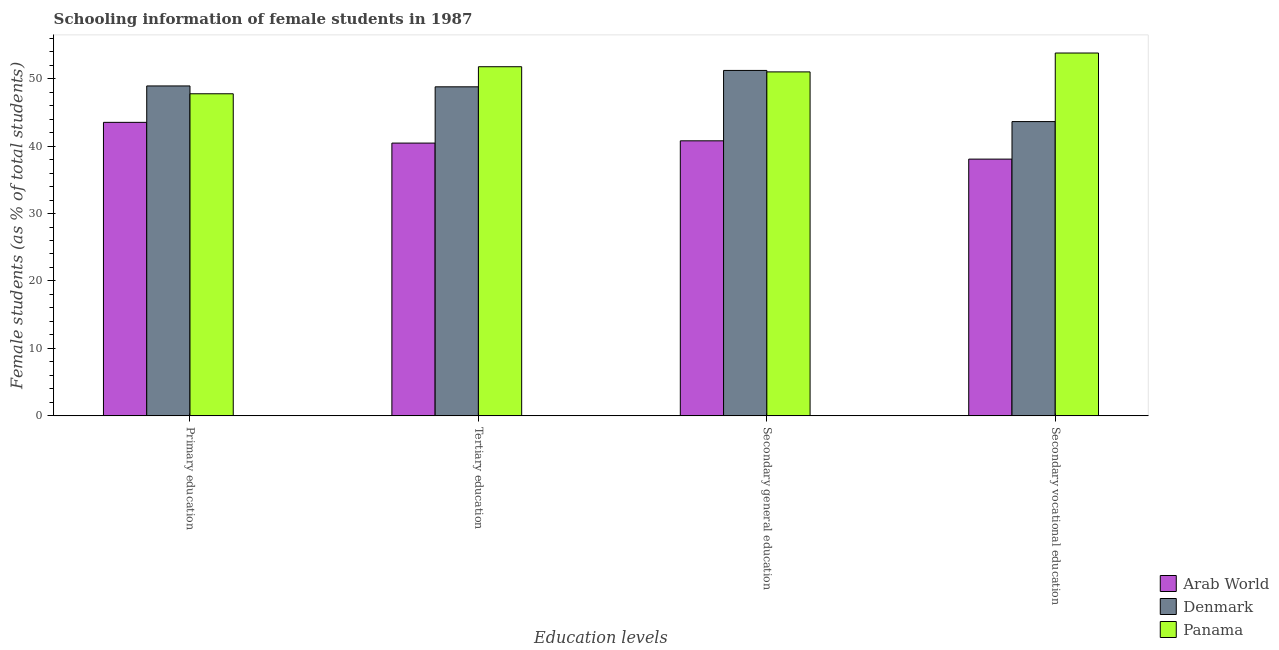Are the number of bars per tick equal to the number of legend labels?
Provide a short and direct response. Yes. What is the label of the 3rd group of bars from the left?
Ensure brevity in your answer.  Secondary general education. What is the percentage of female students in primary education in Panama?
Make the answer very short. 47.75. Across all countries, what is the maximum percentage of female students in primary education?
Offer a terse response. 48.92. Across all countries, what is the minimum percentage of female students in secondary education?
Ensure brevity in your answer.  40.78. In which country was the percentage of female students in secondary education minimum?
Your answer should be compact. Arab World. What is the total percentage of female students in tertiary education in the graph?
Ensure brevity in your answer.  140.99. What is the difference between the percentage of female students in secondary vocational education in Arab World and that in Panama?
Your answer should be very brief. -15.73. What is the difference between the percentage of female students in secondary vocational education in Panama and the percentage of female students in primary education in Arab World?
Provide a succinct answer. 10.28. What is the average percentage of female students in secondary education per country?
Ensure brevity in your answer.  47.66. What is the difference between the percentage of female students in secondary education and percentage of female students in primary education in Panama?
Offer a terse response. 3.24. What is the ratio of the percentage of female students in primary education in Arab World to that in Denmark?
Your answer should be compact. 0.89. Is the percentage of female students in secondary vocational education in Panama less than that in Arab World?
Give a very brief answer. No. What is the difference between the highest and the second highest percentage of female students in secondary vocational education?
Give a very brief answer. 10.17. What is the difference between the highest and the lowest percentage of female students in tertiary education?
Your response must be concise. 11.32. In how many countries, is the percentage of female students in primary education greater than the average percentage of female students in primary education taken over all countries?
Provide a short and direct response. 2. What does the 1st bar from the left in Secondary vocational education represents?
Make the answer very short. Arab World. What does the 3rd bar from the right in Secondary general education represents?
Your response must be concise. Arab World. How many bars are there?
Your answer should be compact. 12. Are all the bars in the graph horizontal?
Your answer should be very brief. No. How many countries are there in the graph?
Offer a very short reply. 3. Are the values on the major ticks of Y-axis written in scientific E-notation?
Give a very brief answer. No. Does the graph contain any zero values?
Give a very brief answer. No. Does the graph contain grids?
Your response must be concise. No. How many legend labels are there?
Provide a short and direct response. 3. What is the title of the graph?
Provide a short and direct response. Schooling information of female students in 1987. What is the label or title of the X-axis?
Offer a very short reply. Education levels. What is the label or title of the Y-axis?
Offer a terse response. Female students (as % of total students). What is the Female students (as % of total students) in Arab World in Primary education?
Offer a terse response. 43.52. What is the Female students (as % of total students) of Denmark in Primary education?
Your response must be concise. 48.92. What is the Female students (as % of total students) of Panama in Primary education?
Your answer should be compact. 47.75. What is the Female students (as % of total students) of Arab World in Tertiary education?
Keep it short and to the point. 40.44. What is the Female students (as % of total students) in Denmark in Tertiary education?
Offer a very short reply. 48.79. What is the Female students (as % of total students) of Panama in Tertiary education?
Your answer should be very brief. 51.76. What is the Female students (as % of total students) in Arab World in Secondary general education?
Make the answer very short. 40.78. What is the Female students (as % of total students) of Denmark in Secondary general education?
Keep it short and to the point. 51.21. What is the Female students (as % of total students) in Panama in Secondary general education?
Make the answer very short. 51. What is the Female students (as % of total students) of Arab World in Secondary vocational education?
Give a very brief answer. 38.07. What is the Female students (as % of total students) of Denmark in Secondary vocational education?
Provide a succinct answer. 43.63. What is the Female students (as % of total students) of Panama in Secondary vocational education?
Ensure brevity in your answer.  53.8. Across all Education levels, what is the maximum Female students (as % of total students) of Arab World?
Give a very brief answer. 43.52. Across all Education levels, what is the maximum Female students (as % of total students) of Denmark?
Provide a succinct answer. 51.21. Across all Education levels, what is the maximum Female students (as % of total students) of Panama?
Provide a succinct answer. 53.8. Across all Education levels, what is the minimum Female students (as % of total students) of Arab World?
Offer a terse response. 38.07. Across all Education levels, what is the minimum Female students (as % of total students) in Denmark?
Make the answer very short. 43.63. Across all Education levels, what is the minimum Female students (as % of total students) of Panama?
Give a very brief answer. 47.75. What is the total Female students (as % of total students) of Arab World in the graph?
Offer a terse response. 162.81. What is the total Female students (as % of total students) in Denmark in the graph?
Your answer should be very brief. 192.54. What is the total Female students (as % of total students) in Panama in the graph?
Give a very brief answer. 204.31. What is the difference between the Female students (as % of total students) in Arab World in Primary education and that in Tertiary education?
Your answer should be very brief. 3.07. What is the difference between the Female students (as % of total students) in Denmark in Primary education and that in Tertiary education?
Offer a very short reply. 0.13. What is the difference between the Female students (as % of total students) of Panama in Primary education and that in Tertiary education?
Ensure brevity in your answer.  -4.01. What is the difference between the Female students (as % of total students) of Arab World in Primary education and that in Secondary general education?
Give a very brief answer. 2.74. What is the difference between the Female students (as % of total students) in Denmark in Primary education and that in Secondary general education?
Offer a very short reply. -2.3. What is the difference between the Female students (as % of total students) of Panama in Primary education and that in Secondary general education?
Make the answer very short. -3.24. What is the difference between the Female students (as % of total students) of Arab World in Primary education and that in Secondary vocational education?
Offer a very short reply. 5.45. What is the difference between the Female students (as % of total students) in Denmark in Primary education and that in Secondary vocational education?
Give a very brief answer. 5.29. What is the difference between the Female students (as % of total students) of Panama in Primary education and that in Secondary vocational education?
Give a very brief answer. -6.04. What is the difference between the Female students (as % of total students) in Arab World in Tertiary education and that in Secondary general education?
Make the answer very short. -0.33. What is the difference between the Female students (as % of total students) in Denmark in Tertiary education and that in Secondary general education?
Keep it short and to the point. -2.43. What is the difference between the Female students (as % of total students) in Panama in Tertiary education and that in Secondary general education?
Keep it short and to the point. 0.77. What is the difference between the Female students (as % of total students) in Arab World in Tertiary education and that in Secondary vocational education?
Offer a very short reply. 2.38. What is the difference between the Female students (as % of total students) of Denmark in Tertiary education and that in Secondary vocational education?
Provide a succinct answer. 5.16. What is the difference between the Female students (as % of total students) of Panama in Tertiary education and that in Secondary vocational education?
Give a very brief answer. -2.03. What is the difference between the Female students (as % of total students) in Arab World in Secondary general education and that in Secondary vocational education?
Offer a very short reply. 2.71. What is the difference between the Female students (as % of total students) in Denmark in Secondary general education and that in Secondary vocational education?
Your answer should be very brief. 7.58. What is the difference between the Female students (as % of total students) in Panama in Secondary general education and that in Secondary vocational education?
Offer a terse response. -2.8. What is the difference between the Female students (as % of total students) in Arab World in Primary education and the Female students (as % of total students) in Denmark in Tertiary education?
Keep it short and to the point. -5.27. What is the difference between the Female students (as % of total students) of Arab World in Primary education and the Female students (as % of total students) of Panama in Tertiary education?
Give a very brief answer. -8.25. What is the difference between the Female students (as % of total students) of Denmark in Primary education and the Female students (as % of total students) of Panama in Tertiary education?
Keep it short and to the point. -2.85. What is the difference between the Female students (as % of total students) of Arab World in Primary education and the Female students (as % of total students) of Denmark in Secondary general education?
Offer a very short reply. -7.7. What is the difference between the Female students (as % of total students) of Arab World in Primary education and the Female students (as % of total students) of Panama in Secondary general education?
Make the answer very short. -7.48. What is the difference between the Female students (as % of total students) in Denmark in Primary education and the Female students (as % of total students) in Panama in Secondary general education?
Your answer should be very brief. -2.08. What is the difference between the Female students (as % of total students) in Arab World in Primary education and the Female students (as % of total students) in Denmark in Secondary vocational education?
Your answer should be compact. -0.11. What is the difference between the Female students (as % of total students) in Arab World in Primary education and the Female students (as % of total students) in Panama in Secondary vocational education?
Provide a succinct answer. -10.28. What is the difference between the Female students (as % of total students) of Denmark in Primary education and the Female students (as % of total students) of Panama in Secondary vocational education?
Provide a succinct answer. -4.88. What is the difference between the Female students (as % of total students) of Arab World in Tertiary education and the Female students (as % of total students) of Denmark in Secondary general education?
Ensure brevity in your answer.  -10.77. What is the difference between the Female students (as % of total students) of Arab World in Tertiary education and the Female students (as % of total students) of Panama in Secondary general education?
Offer a very short reply. -10.55. What is the difference between the Female students (as % of total students) of Denmark in Tertiary education and the Female students (as % of total students) of Panama in Secondary general education?
Offer a very short reply. -2.21. What is the difference between the Female students (as % of total students) of Arab World in Tertiary education and the Female students (as % of total students) of Denmark in Secondary vocational education?
Offer a very short reply. -3.19. What is the difference between the Female students (as % of total students) of Arab World in Tertiary education and the Female students (as % of total students) of Panama in Secondary vocational education?
Give a very brief answer. -13.35. What is the difference between the Female students (as % of total students) of Denmark in Tertiary education and the Female students (as % of total students) of Panama in Secondary vocational education?
Provide a short and direct response. -5.01. What is the difference between the Female students (as % of total students) of Arab World in Secondary general education and the Female students (as % of total students) of Denmark in Secondary vocational education?
Your response must be concise. -2.85. What is the difference between the Female students (as % of total students) in Arab World in Secondary general education and the Female students (as % of total students) in Panama in Secondary vocational education?
Keep it short and to the point. -13.02. What is the difference between the Female students (as % of total students) of Denmark in Secondary general education and the Female students (as % of total students) of Panama in Secondary vocational education?
Your response must be concise. -2.58. What is the average Female students (as % of total students) of Arab World per Education levels?
Make the answer very short. 40.7. What is the average Female students (as % of total students) of Denmark per Education levels?
Offer a terse response. 48.14. What is the average Female students (as % of total students) in Panama per Education levels?
Your answer should be compact. 51.08. What is the difference between the Female students (as % of total students) in Arab World and Female students (as % of total students) in Denmark in Primary education?
Provide a succinct answer. -5.4. What is the difference between the Female students (as % of total students) in Arab World and Female students (as % of total students) in Panama in Primary education?
Give a very brief answer. -4.24. What is the difference between the Female students (as % of total students) of Denmark and Female students (as % of total students) of Panama in Primary education?
Ensure brevity in your answer.  1.16. What is the difference between the Female students (as % of total students) in Arab World and Female students (as % of total students) in Denmark in Tertiary education?
Your answer should be very brief. -8.34. What is the difference between the Female students (as % of total students) of Arab World and Female students (as % of total students) of Panama in Tertiary education?
Give a very brief answer. -11.32. What is the difference between the Female students (as % of total students) in Denmark and Female students (as % of total students) in Panama in Tertiary education?
Your answer should be compact. -2.98. What is the difference between the Female students (as % of total students) in Arab World and Female students (as % of total students) in Denmark in Secondary general education?
Give a very brief answer. -10.44. What is the difference between the Female students (as % of total students) in Arab World and Female students (as % of total students) in Panama in Secondary general education?
Offer a terse response. -10.22. What is the difference between the Female students (as % of total students) in Denmark and Female students (as % of total students) in Panama in Secondary general education?
Your answer should be very brief. 0.22. What is the difference between the Female students (as % of total students) in Arab World and Female students (as % of total students) in Denmark in Secondary vocational education?
Offer a terse response. -5.56. What is the difference between the Female students (as % of total students) of Arab World and Female students (as % of total students) of Panama in Secondary vocational education?
Keep it short and to the point. -15.73. What is the difference between the Female students (as % of total students) in Denmark and Female students (as % of total students) in Panama in Secondary vocational education?
Ensure brevity in your answer.  -10.17. What is the ratio of the Female students (as % of total students) of Arab World in Primary education to that in Tertiary education?
Offer a terse response. 1.08. What is the ratio of the Female students (as % of total students) in Panama in Primary education to that in Tertiary education?
Your answer should be compact. 0.92. What is the ratio of the Female students (as % of total students) of Arab World in Primary education to that in Secondary general education?
Your answer should be very brief. 1.07. What is the ratio of the Female students (as % of total students) of Denmark in Primary education to that in Secondary general education?
Your answer should be compact. 0.96. What is the ratio of the Female students (as % of total students) in Panama in Primary education to that in Secondary general education?
Give a very brief answer. 0.94. What is the ratio of the Female students (as % of total students) of Arab World in Primary education to that in Secondary vocational education?
Keep it short and to the point. 1.14. What is the ratio of the Female students (as % of total students) in Denmark in Primary education to that in Secondary vocational education?
Your answer should be compact. 1.12. What is the ratio of the Female students (as % of total students) of Panama in Primary education to that in Secondary vocational education?
Provide a succinct answer. 0.89. What is the ratio of the Female students (as % of total students) of Denmark in Tertiary education to that in Secondary general education?
Keep it short and to the point. 0.95. What is the ratio of the Female students (as % of total students) of Arab World in Tertiary education to that in Secondary vocational education?
Offer a terse response. 1.06. What is the ratio of the Female students (as % of total students) of Denmark in Tertiary education to that in Secondary vocational education?
Offer a terse response. 1.12. What is the ratio of the Female students (as % of total students) of Panama in Tertiary education to that in Secondary vocational education?
Keep it short and to the point. 0.96. What is the ratio of the Female students (as % of total students) in Arab World in Secondary general education to that in Secondary vocational education?
Keep it short and to the point. 1.07. What is the ratio of the Female students (as % of total students) of Denmark in Secondary general education to that in Secondary vocational education?
Keep it short and to the point. 1.17. What is the ratio of the Female students (as % of total students) of Panama in Secondary general education to that in Secondary vocational education?
Provide a short and direct response. 0.95. What is the difference between the highest and the second highest Female students (as % of total students) in Arab World?
Keep it short and to the point. 2.74. What is the difference between the highest and the second highest Female students (as % of total students) of Denmark?
Provide a short and direct response. 2.3. What is the difference between the highest and the second highest Female students (as % of total students) in Panama?
Ensure brevity in your answer.  2.03. What is the difference between the highest and the lowest Female students (as % of total students) in Arab World?
Ensure brevity in your answer.  5.45. What is the difference between the highest and the lowest Female students (as % of total students) in Denmark?
Make the answer very short. 7.58. What is the difference between the highest and the lowest Female students (as % of total students) in Panama?
Offer a terse response. 6.04. 